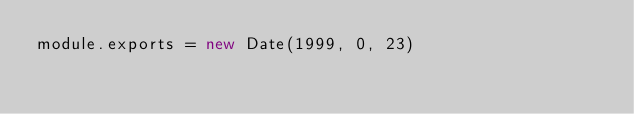<code> <loc_0><loc_0><loc_500><loc_500><_JavaScript_>module.exports = new Date(1999, 0, 23)
</code> 